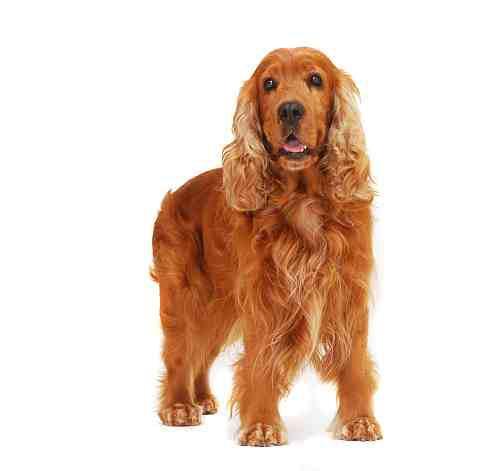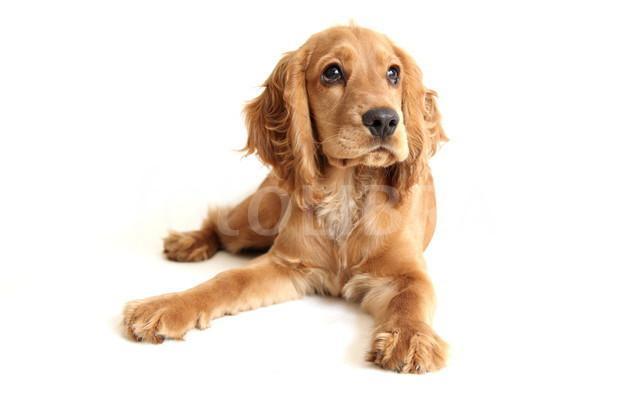The first image is the image on the left, the second image is the image on the right. Evaluate the accuracy of this statement regarding the images: "A single dog tongue can be seen in the image on the left". Is it true? Answer yes or no. Yes. 